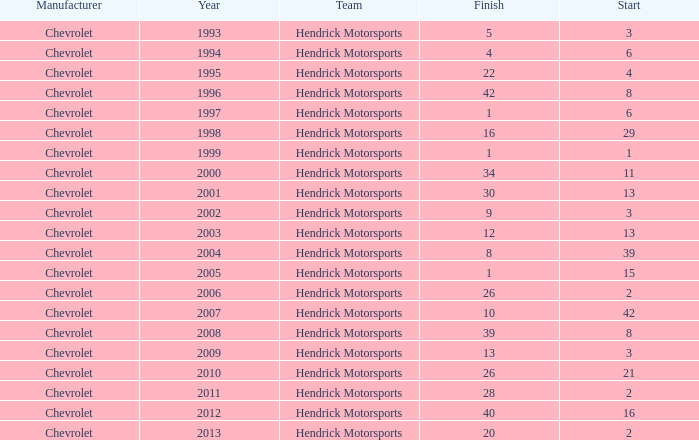What is the number of finishes having a start of 15? 1.0. 